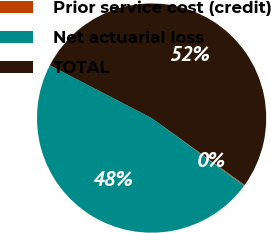Convert chart. <chart><loc_0><loc_0><loc_500><loc_500><pie_chart><fcel>Prior service cost (credit)<fcel>Net actuarial loss<fcel>TOTAL<nl><fcel>0.13%<fcel>47.56%<fcel>52.31%<nl></chart> 